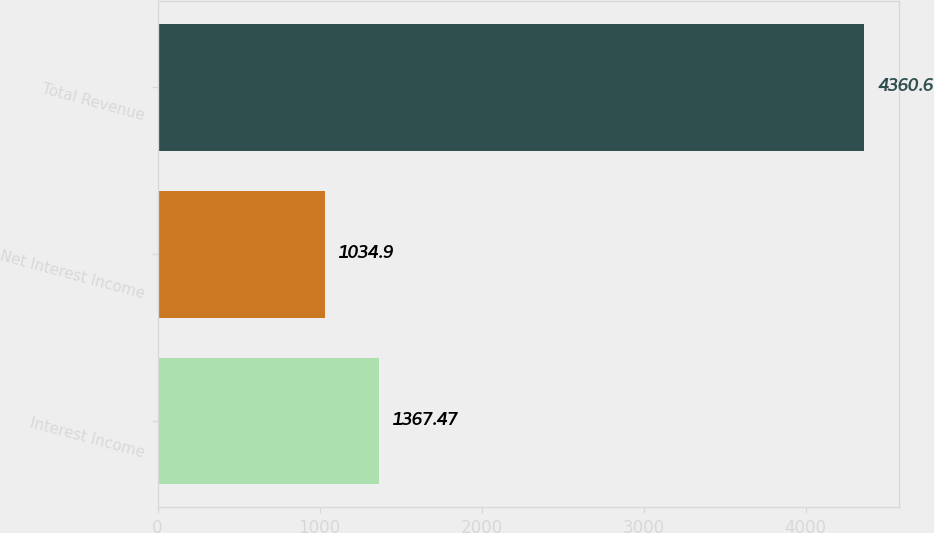<chart> <loc_0><loc_0><loc_500><loc_500><bar_chart><fcel>Interest Income<fcel>Net Interest Income<fcel>Total Revenue<nl><fcel>1367.47<fcel>1034.9<fcel>4360.6<nl></chart> 